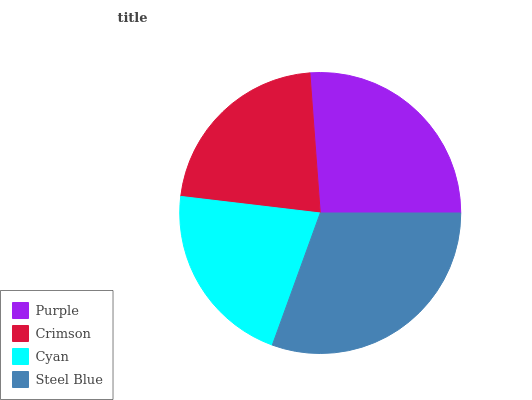Is Cyan the minimum?
Answer yes or no. Yes. Is Steel Blue the maximum?
Answer yes or no. Yes. Is Crimson the minimum?
Answer yes or no. No. Is Crimson the maximum?
Answer yes or no. No. Is Purple greater than Crimson?
Answer yes or no. Yes. Is Crimson less than Purple?
Answer yes or no. Yes. Is Crimson greater than Purple?
Answer yes or no. No. Is Purple less than Crimson?
Answer yes or no. No. Is Purple the high median?
Answer yes or no. Yes. Is Crimson the low median?
Answer yes or no. Yes. Is Crimson the high median?
Answer yes or no. No. Is Cyan the low median?
Answer yes or no. No. 